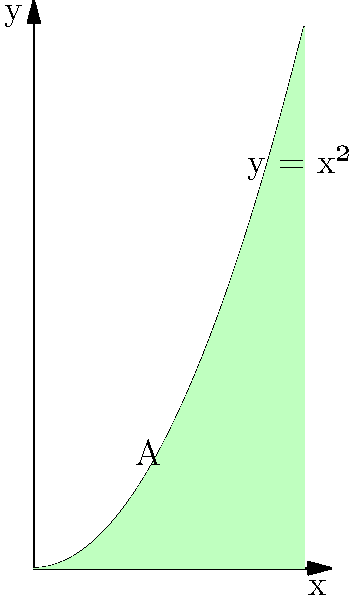As a junior software engineer working on a data visualization project, you need to calculate the area under the curve $y = x^2$ from $x = 0$ to $x = 2$. The shaded region in the graph represents this area. Using integration, determine the value of the shaded area A. Let's approach this step-by-step:

1) The area under the curve is given by the definite integral of the function from 0 to 2.

2) The function is $f(x) = x^2$

3) We need to calculate: $\int_{0}^{2} x^2 dx$

4) To integrate $x^2$, we use the power rule: $\int x^n dx = \frac{x^{n+1}}{n+1} + C$

5) Applying this:
   $\int x^2 dx = \frac{x^3}{3} + C$

6) Now we evaluate this from 0 to 2:
   $[\frac{x^3}{3}]_{0}^{2} = \frac{2^3}{3} - \frac{0^3}{3}$

7) Simplify:
   $\frac{8}{3} - 0 = \frac{8}{3}$

Therefore, the area under the curve from 0 to 2 is $\frac{8}{3}$ square units.
Answer: $\frac{8}{3}$ square units 